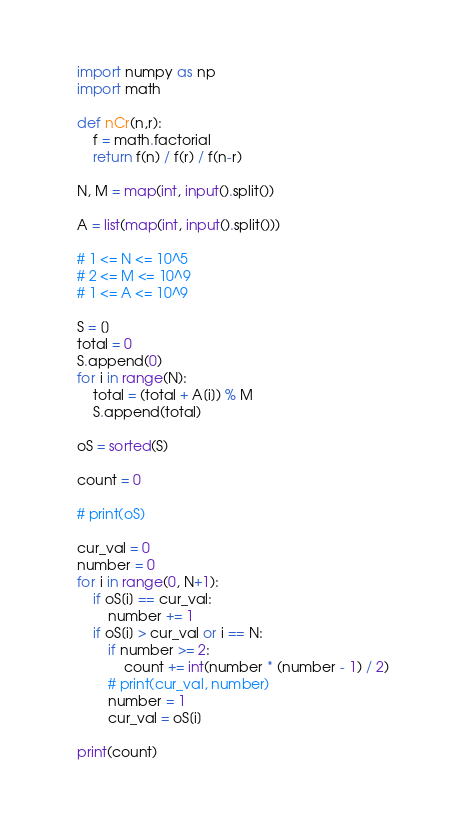<code> <loc_0><loc_0><loc_500><loc_500><_Python_>import numpy as np
import math

def nCr(n,r):
    f = math.factorial
    return f(n) / f(r) / f(n-r)

N, M = map(int, input().split())

A = list(map(int, input().split()))

# 1 <= N <= 10^5
# 2 <= M <= 10^9
# 1 <= A <= 10^9

S = []
total = 0
S.append(0)
for i in range(N):
    total = (total + A[i]) % M
    S.append(total)

oS = sorted(S)

count = 0

# print(oS)

cur_val = 0
number = 0
for i in range(0, N+1):
    if oS[i] == cur_val:
        number += 1
    if oS[i] > cur_val or i == N:
        if number >= 2:
            count += int(number * (number - 1) / 2)
        # print(cur_val, number)
        number = 1
        cur_val = oS[i]

print(count)
</code> 